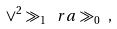<formula> <loc_0><loc_0><loc_500><loc_500>\vee ^ { 2 } \gg _ { 1 } \ r a \gg _ { 0 } \ ,</formula> 